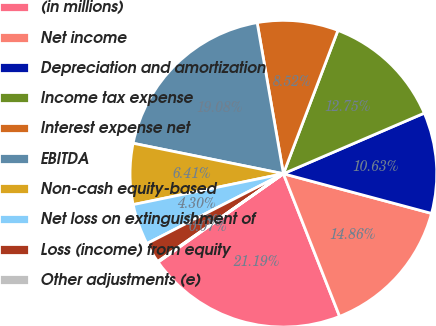Convert chart. <chart><loc_0><loc_0><loc_500><loc_500><pie_chart><fcel>(in millions)<fcel>Net income<fcel>Depreciation and amortization<fcel>Income tax expense<fcel>Interest expense net<fcel>EBITDA<fcel>Non-cash equity-based<fcel>Net loss on extinguishment of<fcel>Loss (income) from equity<fcel>Other adjustments (e)<nl><fcel>21.19%<fcel>14.86%<fcel>10.63%<fcel>12.75%<fcel>8.52%<fcel>19.08%<fcel>6.41%<fcel>4.3%<fcel>2.18%<fcel>0.07%<nl></chart> 